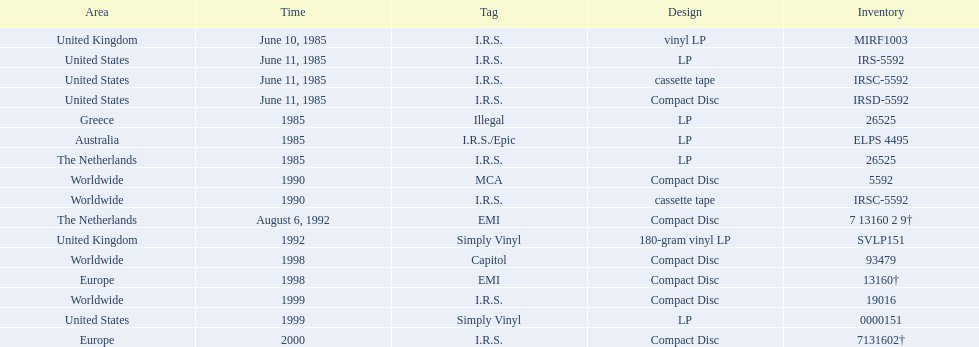In how many countries was the album released before 1990? 5. 